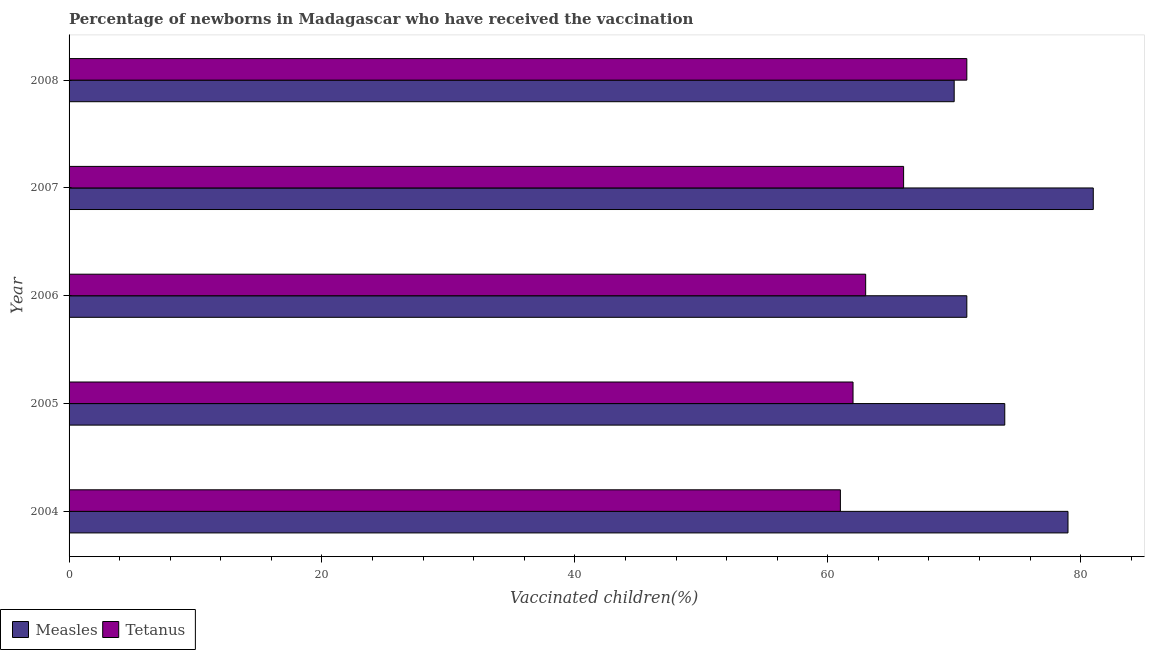How many different coloured bars are there?
Give a very brief answer. 2. Are the number of bars per tick equal to the number of legend labels?
Your answer should be compact. Yes. Are the number of bars on each tick of the Y-axis equal?
Give a very brief answer. Yes. How many bars are there on the 2nd tick from the top?
Your response must be concise. 2. How many bars are there on the 2nd tick from the bottom?
Your response must be concise. 2. What is the percentage of newborns who received vaccination for measles in 2007?
Keep it short and to the point. 81. Across all years, what is the maximum percentage of newborns who received vaccination for measles?
Provide a succinct answer. 81. Across all years, what is the minimum percentage of newborns who received vaccination for measles?
Provide a short and direct response. 70. In which year was the percentage of newborns who received vaccination for measles maximum?
Give a very brief answer. 2007. In which year was the percentage of newborns who received vaccination for measles minimum?
Provide a succinct answer. 2008. What is the total percentage of newborns who received vaccination for measles in the graph?
Give a very brief answer. 375. What is the difference between the percentage of newborns who received vaccination for measles in 2004 and that in 2006?
Your answer should be compact. 8. What is the difference between the percentage of newborns who received vaccination for tetanus in 2008 and the percentage of newborns who received vaccination for measles in 2004?
Provide a short and direct response. -8. What is the average percentage of newborns who received vaccination for tetanus per year?
Make the answer very short. 64.6. In the year 2005, what is the difference between the percentage of newborns who received vaccination for measles and percentage of newborns who received vaccination for tetanus?
Your response must be concise. 12. In how many years, is the percentage of newborns who received vaccination for measles greater than 44 %?
Your response must be concise. 5. What is the ratio of the percentage of newborns who received vaccination for measles in 2004 to that in 2008?
Provide a short and direct response. 1.13. What is the difference between the highest and the second highest percentage of newborns who received vaccination for measles?
Keep it short and to the point. 2. What is the difference between the highest and the lowest percentage of newborns who received vaccination for tetanus?
Give a very brief answer. 10. In how many years, is the percentage of newborns who received vaccination for tetanus greater than the average percentage of newborns who received vaccination for tetanus taken over all years?
Make the answer very short. 2. Is the sum of the percentage of newborns who received vaccination for tetanus in 2004 and 2005 greater than the maximum percentage of newborns who received vaccination for measles across all years?
Ensure brevity in your answer.  Yes. What does the 1st bar from the top in 2006 represents?
Keep it short and to the point. Tetanus. What does the 1st bar from the bottom in 2004 represents?
Make the answer very short. Measles. What is the difference between two consecutive major ticks on the X-axis?
Provide a succinct answer. 20. How many legend labels are there?
Offer a terse response. 2. How are the legend labels stacked?
Your answer should be compact. Horizontal. What is the title of the graph?
Your answer should be very brief. Percentage of newborns in Madagascar who have received the vaccination. What is the label or title of the X-axis?
Your response must be concise. Vaccinated children(%)
. What is the Vaccinated children(%)
 of Measles in 2004?
Your response must be concise. 79. What is the Vaccinated children(%)
 in Tetanus in 2004?
Provide a short and direct response. 61. What is the Vaccinated children(%)
 of Measles in 2005?
Keep it short and to the point. 74. What is the Vaccinated children(%)
 in Tetanus in 2005?
Offer a terse response. 62. What is the Vaccinated children(%)
 in Measles in 2007?
Offer a very short reply. 81. Across all years, what is the maximum Vaccinated children(%)
 in Measles?
Ensure brevity in your answer.  81. Across all years, what is the minimum Vaccinated children(%)
 of Measles?
Your answer should be compact. 70. Across all years, what is the minimum Vaccinated children(%)
 of Tetanus?
Provide a short and direct response. 61. What is the total Vaccinated children(%)
 of Measles in the graph?
Provide a short and direct response. 375. What is the total Vaccinated children(%)
 of Tetanus in the graph?
Keep it short and to the point. 323. What is the difference between the Vaccinated children(%)
 of Measles in 2004 and that in 2006?
Your answer should be compact. 8. What is the difference between the Vaccinated children(%)
 in Tetanus in 2004 and that in 2006?
Keep it short and to the point. -2. What is the difference between the Vaccinated children(%)
 in Tetanus in 2004 and that in 2007?
Offer a very short reply. -5. What is the difference between the Vaccinated children(%)
 in Measles in 2004 and that in 2008?
Your response must be concise. 9. What is the difference between the Vaccinated children(%)
 in Tetanus in 2004 and that in 2008?
Offer a terse response. -10. What is the difference between the Vaccinated children(%)
 of Measles in 2005 and that in 2008?
Offer a terse response. 4. What is the difference between the Vaccinated children(%)
 in Measles in 2006 and that in 2007?
Make the answer very short. -10. What is the difference between the Vaccinated children(%)
 in Measles in 2006 and that in 2008?
Your response must be concise. 1. What is the difference between the Vaccinated children(%)
 in Tetanus in 2006 and that in 2008?
Provide a short and direct response. -8. What is the difference between the Vaccinated children(%)
 of Measles in 2004 and the Vaccinated children(%)
 of Tetanus in 2005?
Offer a very short reply. 17. What is the difference between the Vaccinated children(%)
 of Measles in 2004 and the Vaccinated children(%)
 of Tetanus in 2006?
Make the answer very short. 16. What is the difference between the Vaccinated children(%)
 in Measles in 2005 and the Vaccinated children(%)
 in Tetanus in 2008?
Provide a short and direct response. 3. What is the average Vaccinated children(%)
 of Measles per year?
Offer a very short reply. 75. What is the average Vaccinated children(%)
 in Tetanus per year?
Provide a short and direct response. 64.6. In the year 2004, what is the difference between the Vaccinated children(%)
 in Measles and Vaccinated children(%)
 in Tetanus?
Your answer should be very brief. 18. In the year 2006, what is the difference between the Vaccinated children(%)
 of Measles and Vaccinated children(%)
 of Tetanus?
Ensure brevity in your answer.  8. In the year 2007, what is the difference between the Vaccinated children(%)
 in Measles and Vaccinated children(%)
 in Tetanus?
Give a very brief answer. 15. In the year 2008, what is the difference between the Vaccinated children(%)
 of Measles and Vaccinated children(%)
 of Tetanus?
Give a very brief answer. -1. What is the ratio of the Vaccinated children(%)
 of Measles in 2004 to that in 2005?
Ensure brevity in your answer.  1.07. What is the ratio of the Vaccinated children(%)
 in Tetanus in 2004 to that in 2005?
Provide a succinct answer. 0.98. What is the ratio of the Vaccinated children(%)
 of Measles in 2004 to that in 2006?
Offer a terse response. 1.11. What is the ratio of the Vaccinated children(%)
 of Tetanus in 2004 to that in 2006?
Give a very brief answer. 0.97. What is the ratio of the Vaccinated children(%)
 in Measles in 2004 to that in 2007?
Provide a short and direct response. 0.98. What is the ratio of the Vaccinated children(%)
 in Tetanus in 2004 to that in 2007?
Make the answer very short. 0.92. What is the ratio of the Vaccinated children(%)
 of Measles in 2004 to that in 2008?
Provide a short and direct response. 1.13. What is the ratio of the Vaccinated children(%)
 in Tetanus in 2004 to that in 2008?
Provide a succinct answer. 0.86. What is the ratio of the Vaccinated children(%)
 in Measles in 2005 to that in 2006?
Your answer should be compact. 1.04. What is the ratio of the Vaccinated children(%)
 of Tetanus in 2005 to that in 2006?
Make the answer very short. 0.98. What is the ratio of the Vaccinated children(%)
 in Measles in 2005 to that in 2007?
Provide a succinct answer. 0.91. What is the ratio of the Vaccinated children(%)
 of Tetanus in 2005 to that in 2007?
Ensure brevity in your answer.  0.94. What is the ratio of the Vaccinated children(%)
 of Measles in 2005 to that in 2008?
Ensure brevity in your answer.  1.06. What is the ratio of the Vaccinated children(%)
 of Tetanus in 2005 to that in 2008?
Offer a very short reply. 0.87. What is the ratio of the Vaccinated children(%)
 in Measles in 2006 to that in 2007?
Your response must be concise. 0.88. What is the ratio of the Vaccinated children(%)
 of Tetanus in 2006 to that in 2007?
Your response must be concise. 0.95. What is the ratio of the Vaccinated children(%)
 in Measles in 2006 to that in 2008?
Offer a very short reply. 1.01. What is the ratio of the Vaccinated children(%)
 in Tetanus in 2006 to that in 2008?
Give a very brief answer. 0.89. What is the ratio of the Vaccinated children(%)
 of Measles in 2007 to that in 2008?
Provide a short and direct response. 1.16. What is the ratio of the Vaccinated children(%)
 in Tetanus in 2007 to that in 2008?
Ensure brevity in your answer.  0.93. What is the difference between the highest and the lowest Vaccinated children(%)
 of Tetanus?
Ensure brevity in your answer.  10. 